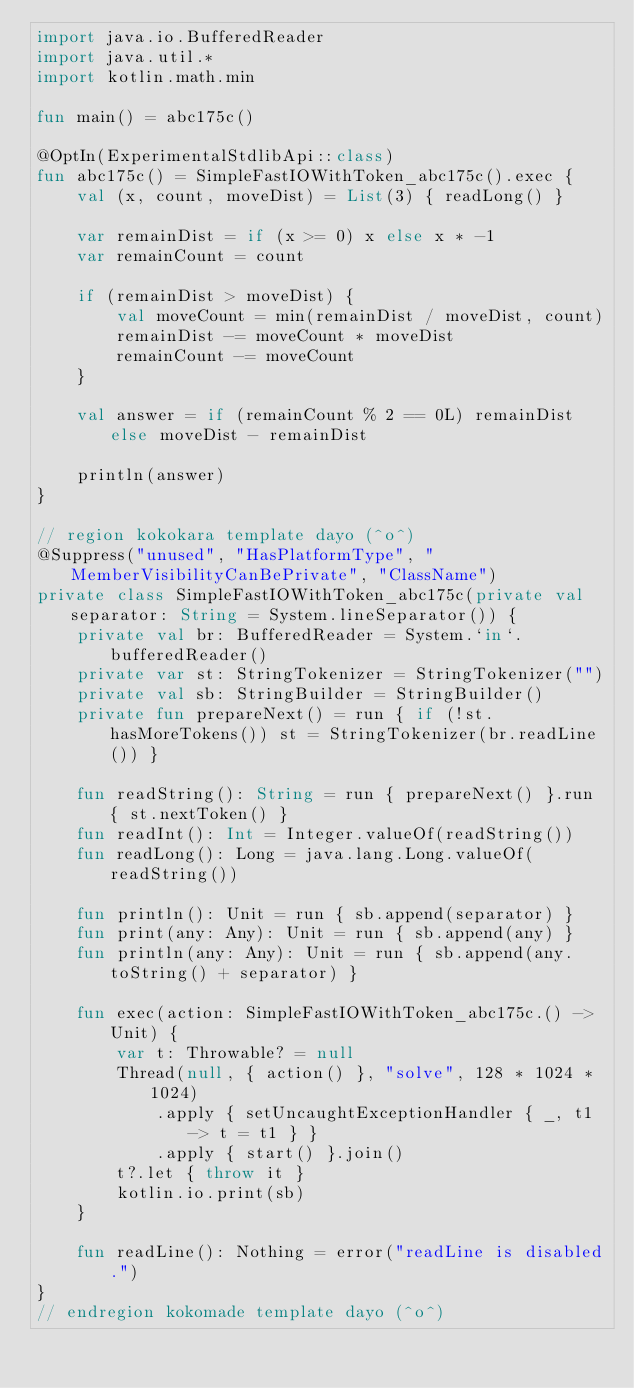Convert code to text. <code><loc_0><loc_0><loc_500><loc_500><_Kotlin_>import java.io.BufferedReader
import java.util.*
import kotlin.math.min

fun main() = abc175c()

@OptIn(ExperimentalStdlibApi::class)
fun abc175c() = SimpleFastIOWithToken_abc175c().exec {
    val (x, count, moveDist) = List(3) { readLong() }

    var remainDist = if (x >= 0) x else x * -1
    var remainCount = count

    if (remainDist > moveDist) {
        val moveCount = min(remainDist / moveDist, count)
        remainDist -= moveCount * moveDist
        remainCount -= moveCount
    }

    val answer = if (remainCount % 2 == 0L) remainDist else moveDist - remainDist

    println(answer)
}

// region kokokara template dayo (^o^)
@Suppress("unused", "HasPlatformType", "MemberVisibilityCanBePrivate", "ClassName")
private class SimpleFastIOWithToken_abc175c(private val separator: String = System.lineSeparator()) {
    private val br: BufferedReader = System.`in`.bufferedReader()
    private var st: StringTokenizer = StringTokenizer("")
    private val sb: StringBuilder = StringBuilder()
    private fun prepareNext() = run { if (!st.hasMoreTokens()) st = StringTokenizer(br.readLine()) }

    fun readString(): String = run { prepareNext() }.run { st.nextToken() }
    fun readInt(): Int = Integer.valueOf(readString())
    fun readLong(): Long = java.lang.Long.valueOf(readString())

    fun println(): Unit = run { sb.append(separator) }
    fun print(any: Any): Unit = run { sb.append(any) }
    fun println(any: Any): Unit = run { sb.append(any.toString() + separator) }

    fun exec(action: SimpleFastIOWithToken_abc175c.() -> Unit) {
        var t: Throwable? = null
        Thread(null, { action() }, "solve", 128 * 1024 * 1024)
            .apply { setUncaughtExceptionHandler { _, t1 -> t = t1 } }
            .apply { start() }.join()
        t?.let { throw it }
        kotlin.io.print(sb)
    }

    fun readLine(): Nothing = error("readLine is disabled.")
}
// endregion kokomade template dayo (^o^)
</code> 